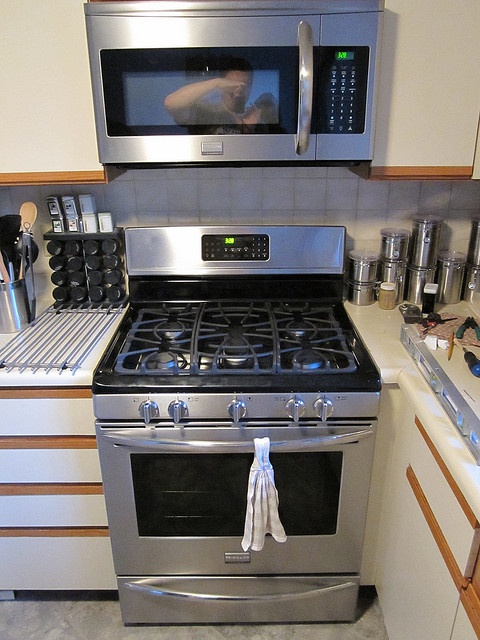Describe the objects in this image and their specific colors. I can see oven in tan, black, gray, and darkgray tones, microwave in tan, black, gray, and darkgray tones, people in tan, gray, and black tones, spoon in tan, black, gray, and darkgray tones, and spoon in tan tones in this image. 